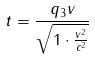<formula> <loc_0><loc_0><loc_500><loc_500>t = \frac { q _ { 3 } v } { \sqrt { 1 \cdot \frac { v ^ { 2 } } { c ^ { 2 } } } }</formula> 